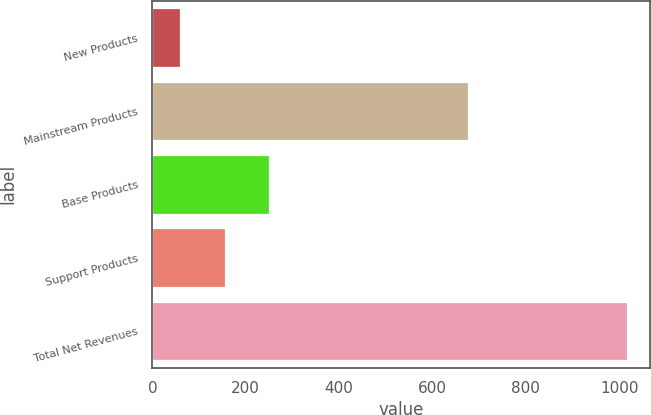<chart> <loc_0><loc_0><loc_500><loc_500><bar_chart><fcel>New Products<fcel>Mainstream Products<fcel>Base Products<fcel>Support Products<fcel>Total Net Revenues<nl><fcel>58.9<fcel>676.2<fcel>250.24<fcel>154.57<fcel>1015.6<nl></chart> 